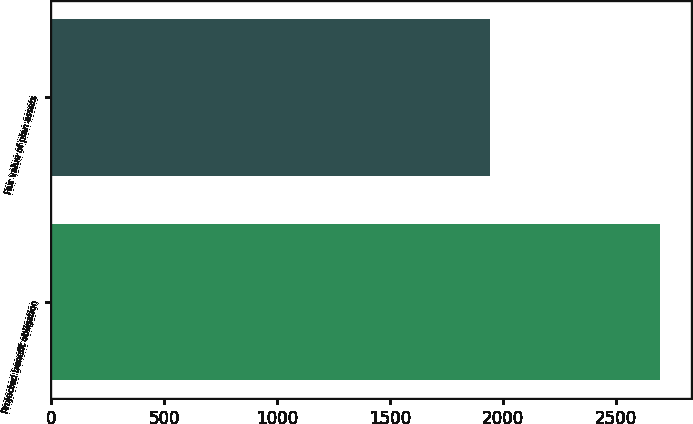Convert chart. <chart><loc_0><loc_0><loc_500><loc_500><bar_chart><fcel>Projected benefit obligation<fcel>Fair value of plan assets<nl><fcel>2697<fcel>1942<nl></chart> 